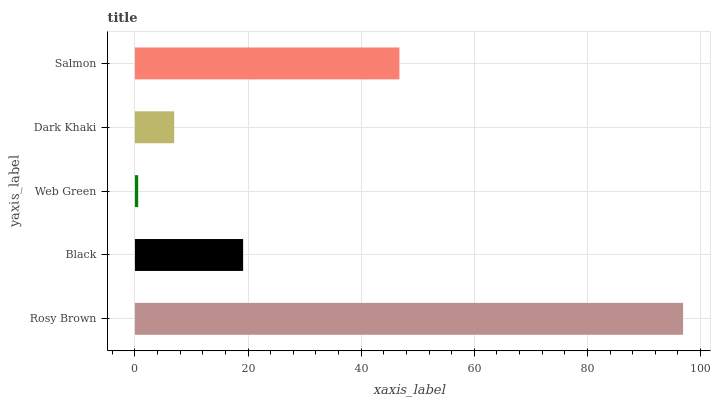Is Web Green the minimum?
Answer yes or no. Yes. Is Rosy Brown the maximum?
Answer yes or no. Yes. Is Black the minimum?
Answer yes or no. No. Is Black the maximum?
Answer yes or no. No. Is Rosy Brown greater than Black?
Answer yes or no. Yes. Is Black less than Rosy Brown?
Answer yes or no. Yes. Is Black greater than Rosy Brown?
Answer yes or no. No. Is Rosy Brown less than Black?
Answer yes or no. No. Is Black the high median?
Answer yes or no. Yes. Is Black the low median?
Answer yes or no. Yes. Is Rosy Brown the high median?
Answer yes or no. No. Is Rosy Brown the low median?
Answer yes or no. No. 